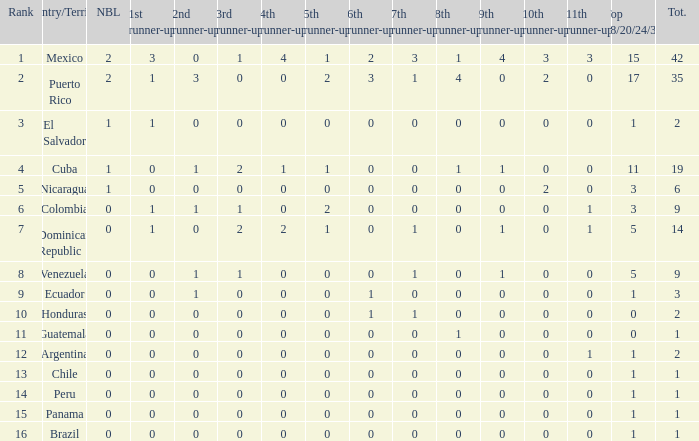What is the average total of the country with a 4th runner-up of 0 and a Nuestra Bellaza Latina less than 0? None. 